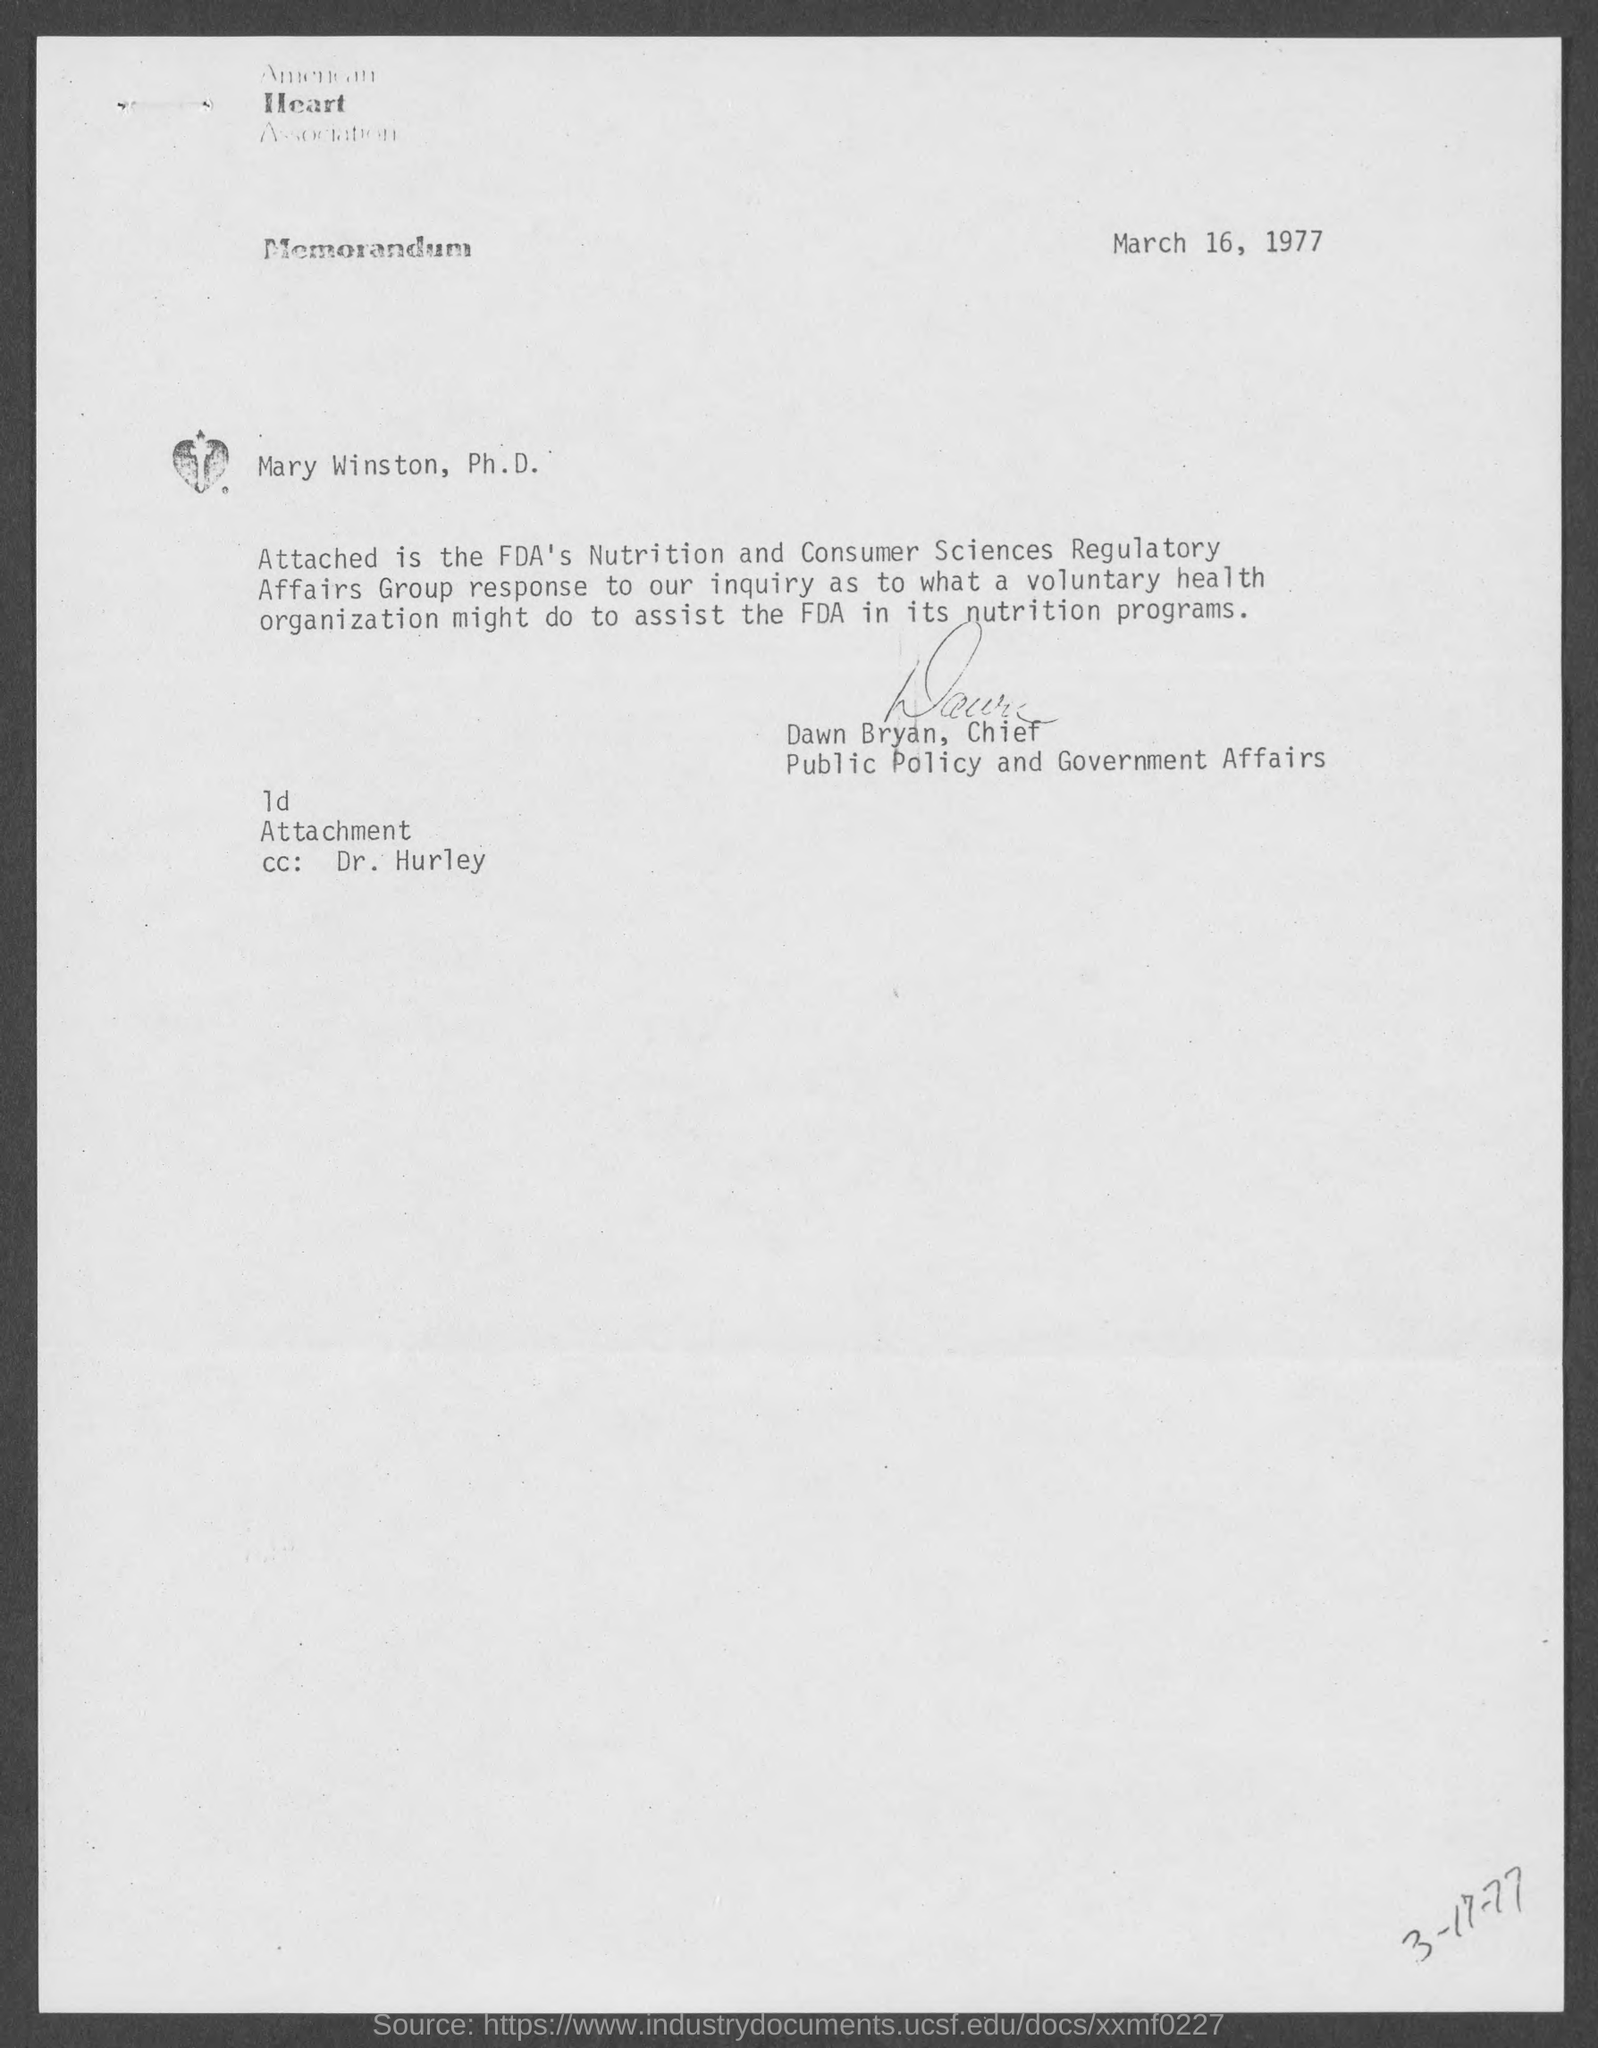Draw attention to some important aspects in this diagram. The American Heart Association is the name of the organization located at the top of the page. The memorandum is dated March 16, 1977. It is known that the Chief of Public Policy and Government Affairs is named Dawn Bryan. 